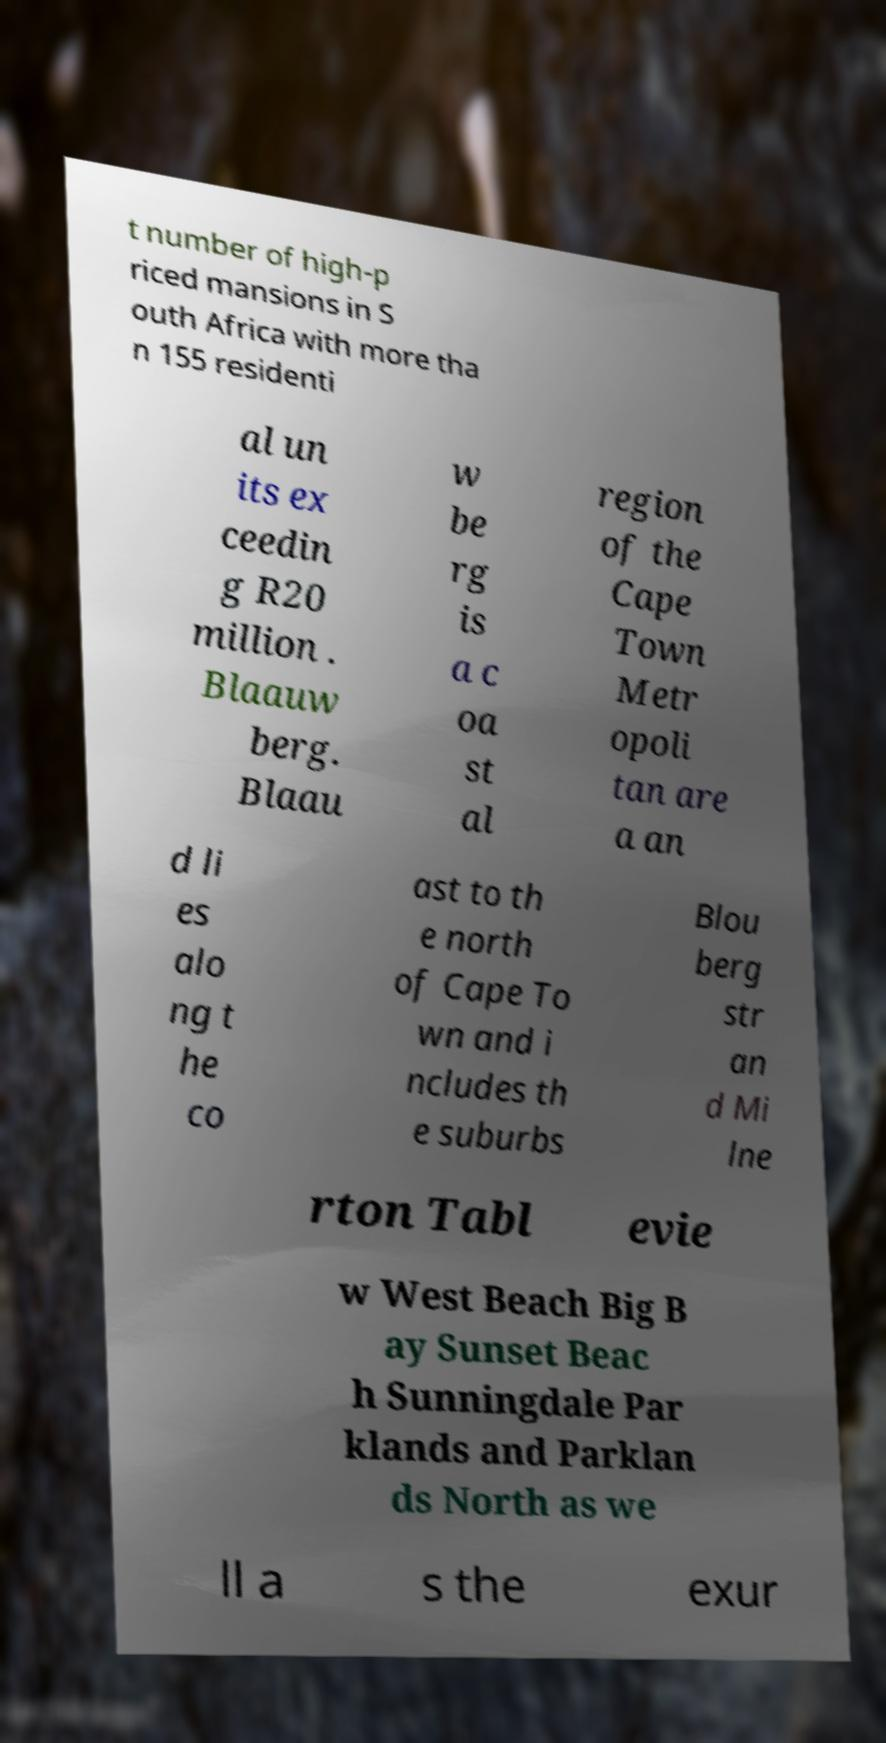For documentation purposes, I need the text within this image transcribed. Could you provide that? t number of high-p riced mansions in S outh Africa with more tha n 155 residenti al un its ex ceedin g R20 million . Blaauw berg. Blaau w be rg is a c oa st al region of the Cape Town Metr opoli tan are a an d li es alo ng t he co ast to th e north of Cape To wn and i ncludes th e suburbs Blou berg str an d Mi lne rton Tabl evie w West Beach Big B ay Sunset Beac h Sunningdale Par klands and Parklan ds North as we ll a s the exur 